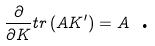Convert formula to latex. <formula><loc_0><loc_0><loc_500><loc_500>\frac { \partial } { \partial K } t r \left ( A K ^ { \prime } \right ) = A \text { .}</formula> 